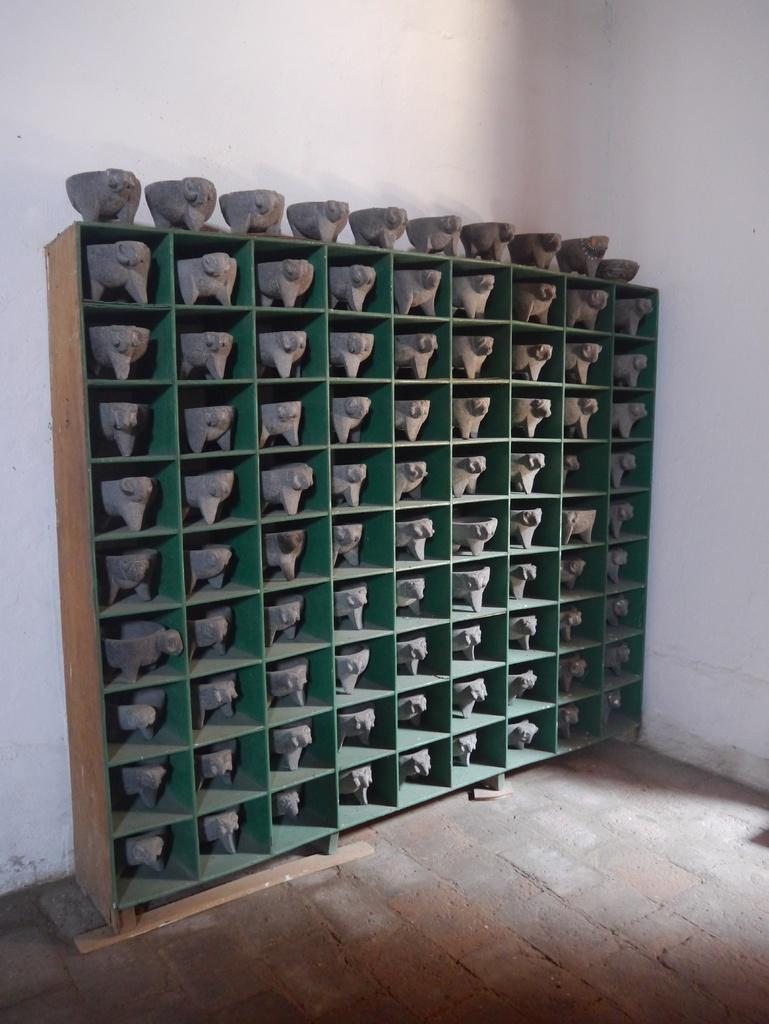What type of objects can be seen in the image? There are sculptures in the image. How are the sculptures arranged? The sculptures are placed in a rack. What can be seen in the background of the image? There is a wall in the background of the image. What number is written on the sculpture in the image? There is no number written on any of the sculptures in the image. 